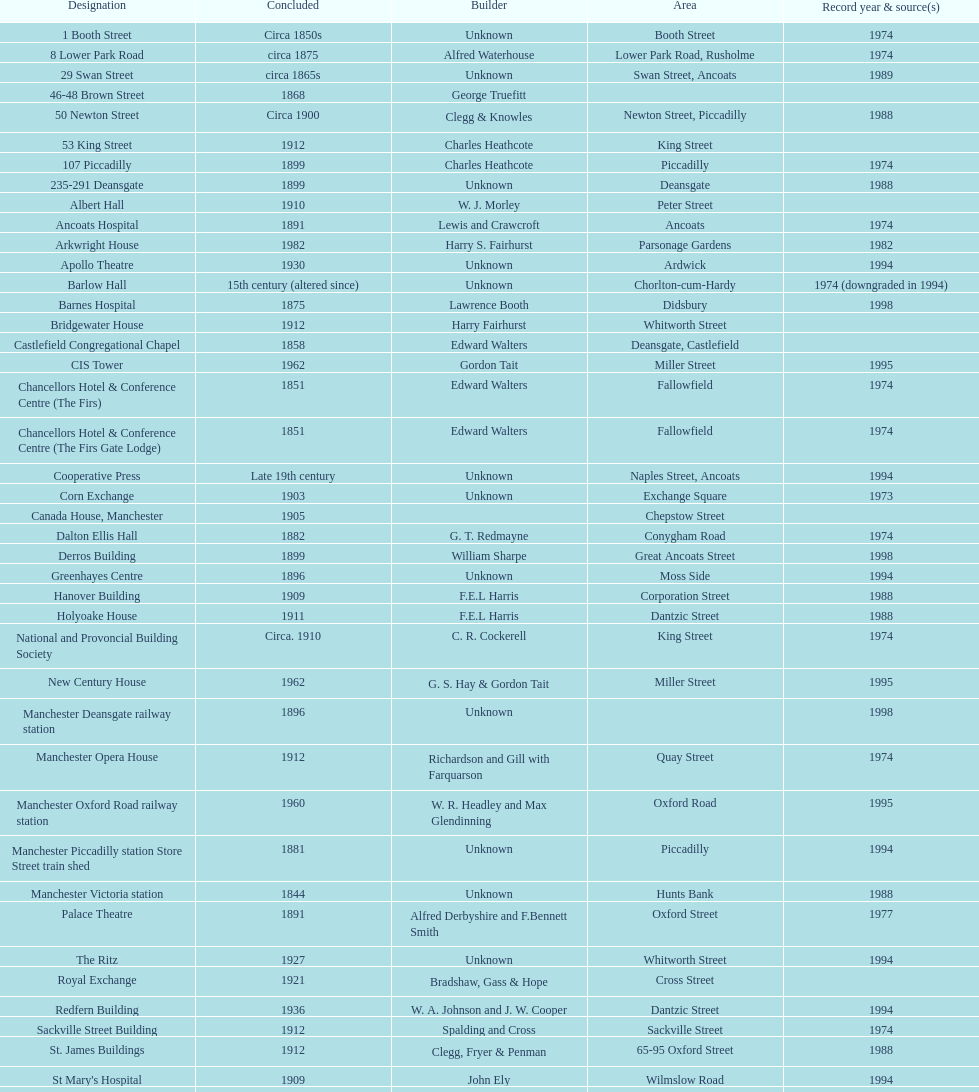What is the street of the only building listed in 1989? Swan Street. 